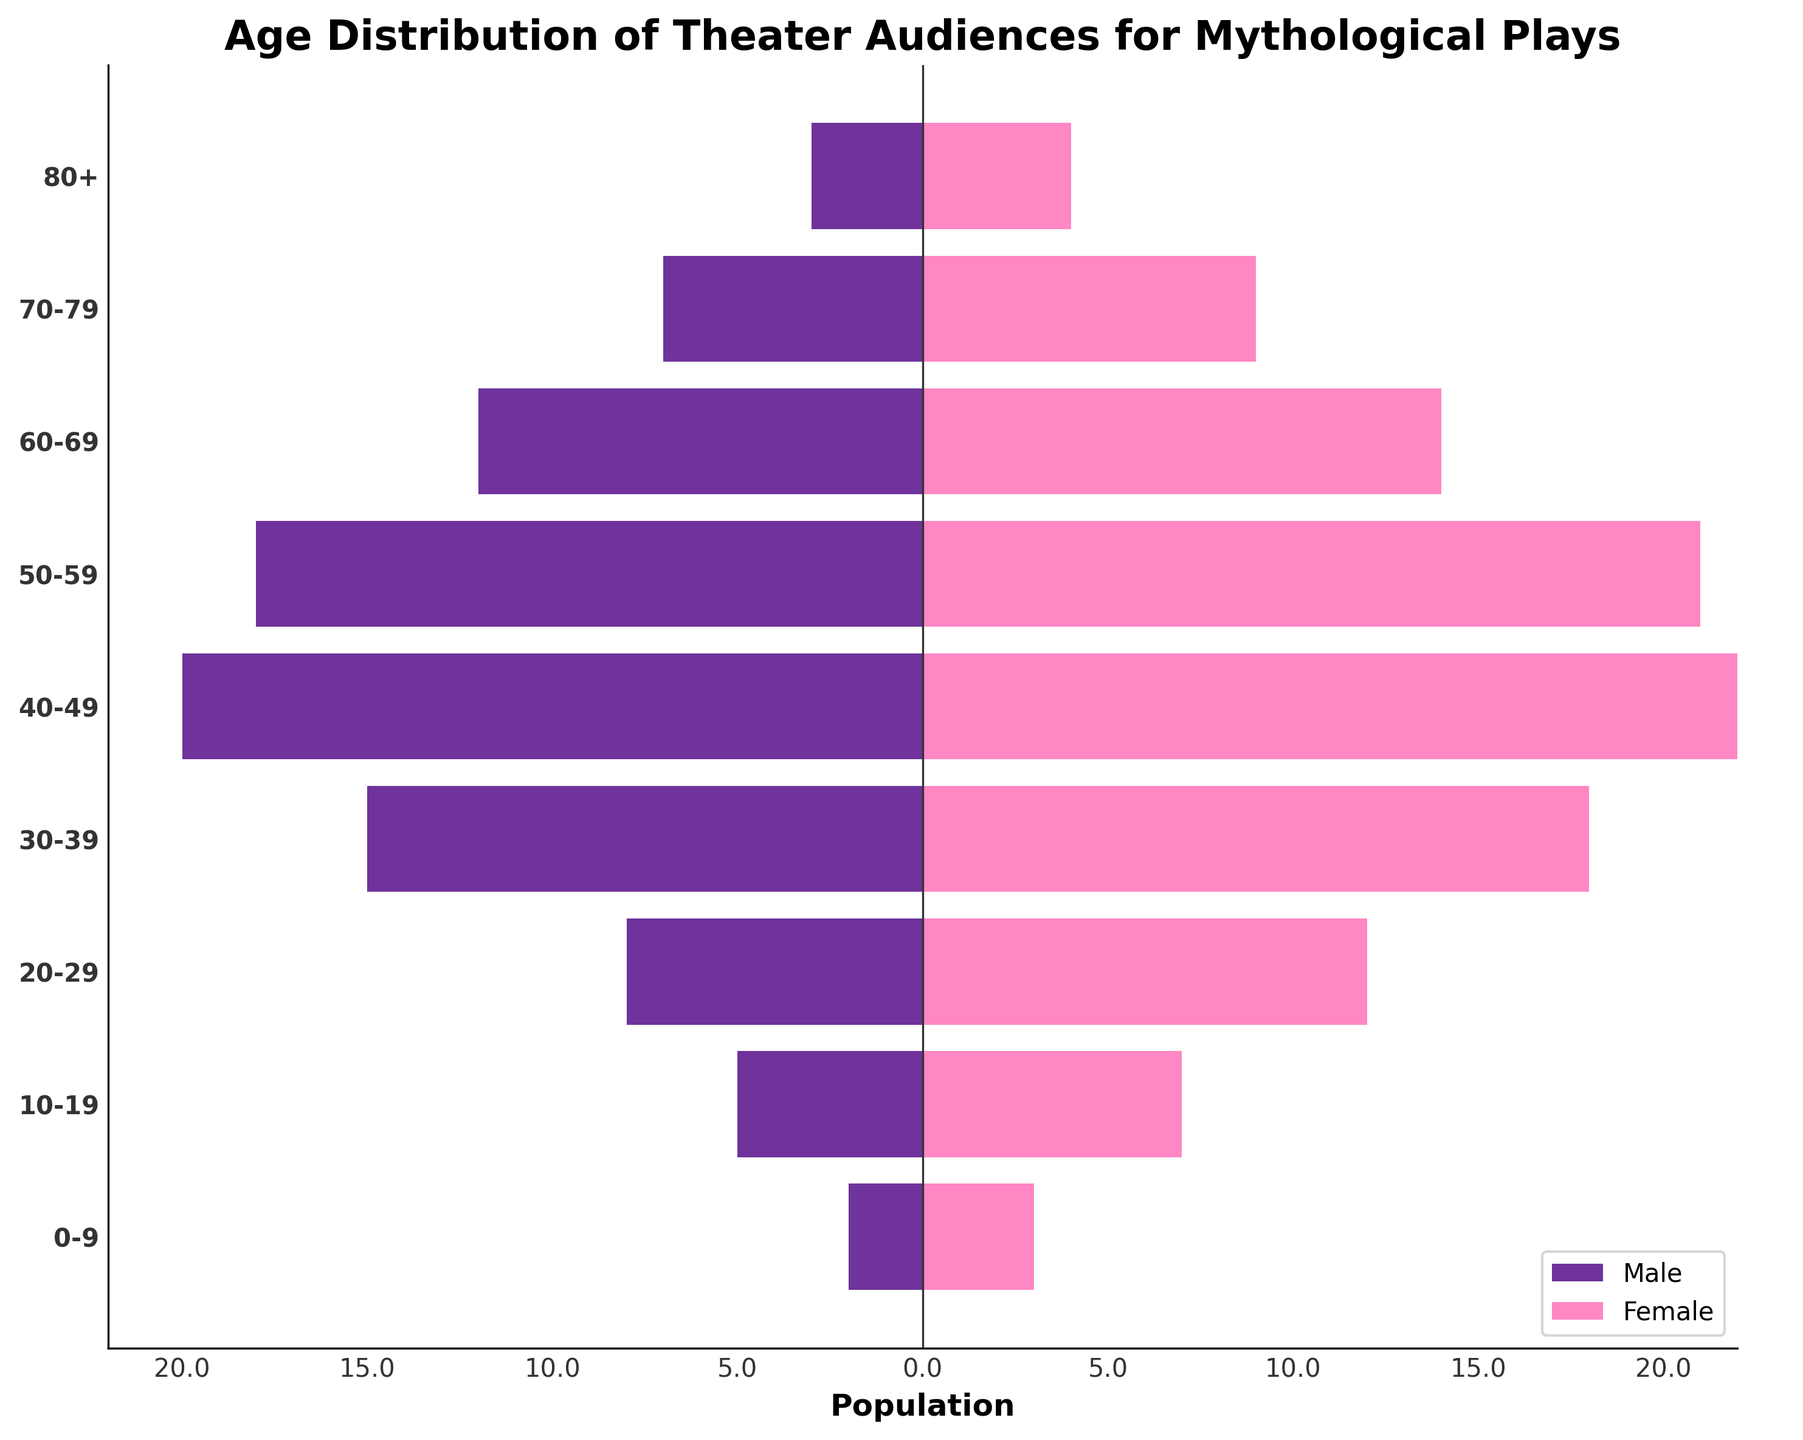What is the title of the figure? The title of the figure is located at the top and is bold and in a larger font size that stands out from the rest of the text. It states what the graph is about specifically related to the audience's age and gender distribution.
Answer: Age Distribution of Theater Audiences for Mythological Plays Which gender has more audience members in the age group 40-49? The age group 40-49 in the horizontal bar graph has both male and female bars and we need to compare their lengths. The female bar is slightly longer than the male bar.
Answer: Female How does the number of male audience members aged 50-59 compare to those aged 60-69? We need to compare the bar lengths for males in the age groups 50-59 and 60-69. The bar for the age group 50-59 is longer than that for 60-69.
Answer: More in 50-59 What is the combined total for both males and females in the age group 20-29? Add the values for males and females in the age group 20-29. Males are 8 and females are 12, combining them gives 20.
Answer: 20 Which age group has the smallest difference in the number of males and females? Calculate the absolute difference between the values for males and females for each age group, and find the one with the smallest value. The absolute difference for the 70-79 age group is the lowest, which is 2.
Answer: 70-79 What pattern can be observed about the audience's age distribution? Interpret the general trend of the graph where the middle age groups seem to have larger audience numbers than the younger and older age groups. Most audience members fall between the ages 30 and 59.
Answer: Middle-aged groups dominate What is the median age group for the female audience? Identify the age groups and their female population values. There are 9 age groups, the median age group is the one that falls in the middle, which is the 40-49 age group.
Answer: 40-49 Which two adjacent age groups have the highest combined female audience? For female values, calculate the combined values for each pair of adjacent groups. Comparing these sums reveals that the combined highest is from age groups 30-39 and 40-49 which total 18+22=40.
Answer: 30-39 and 40-49 Which age group has the highest male audience? From the figure, identify the age group with the longest horizontal bar for males, which is the 40-49 age group.
Answer: 40-49 